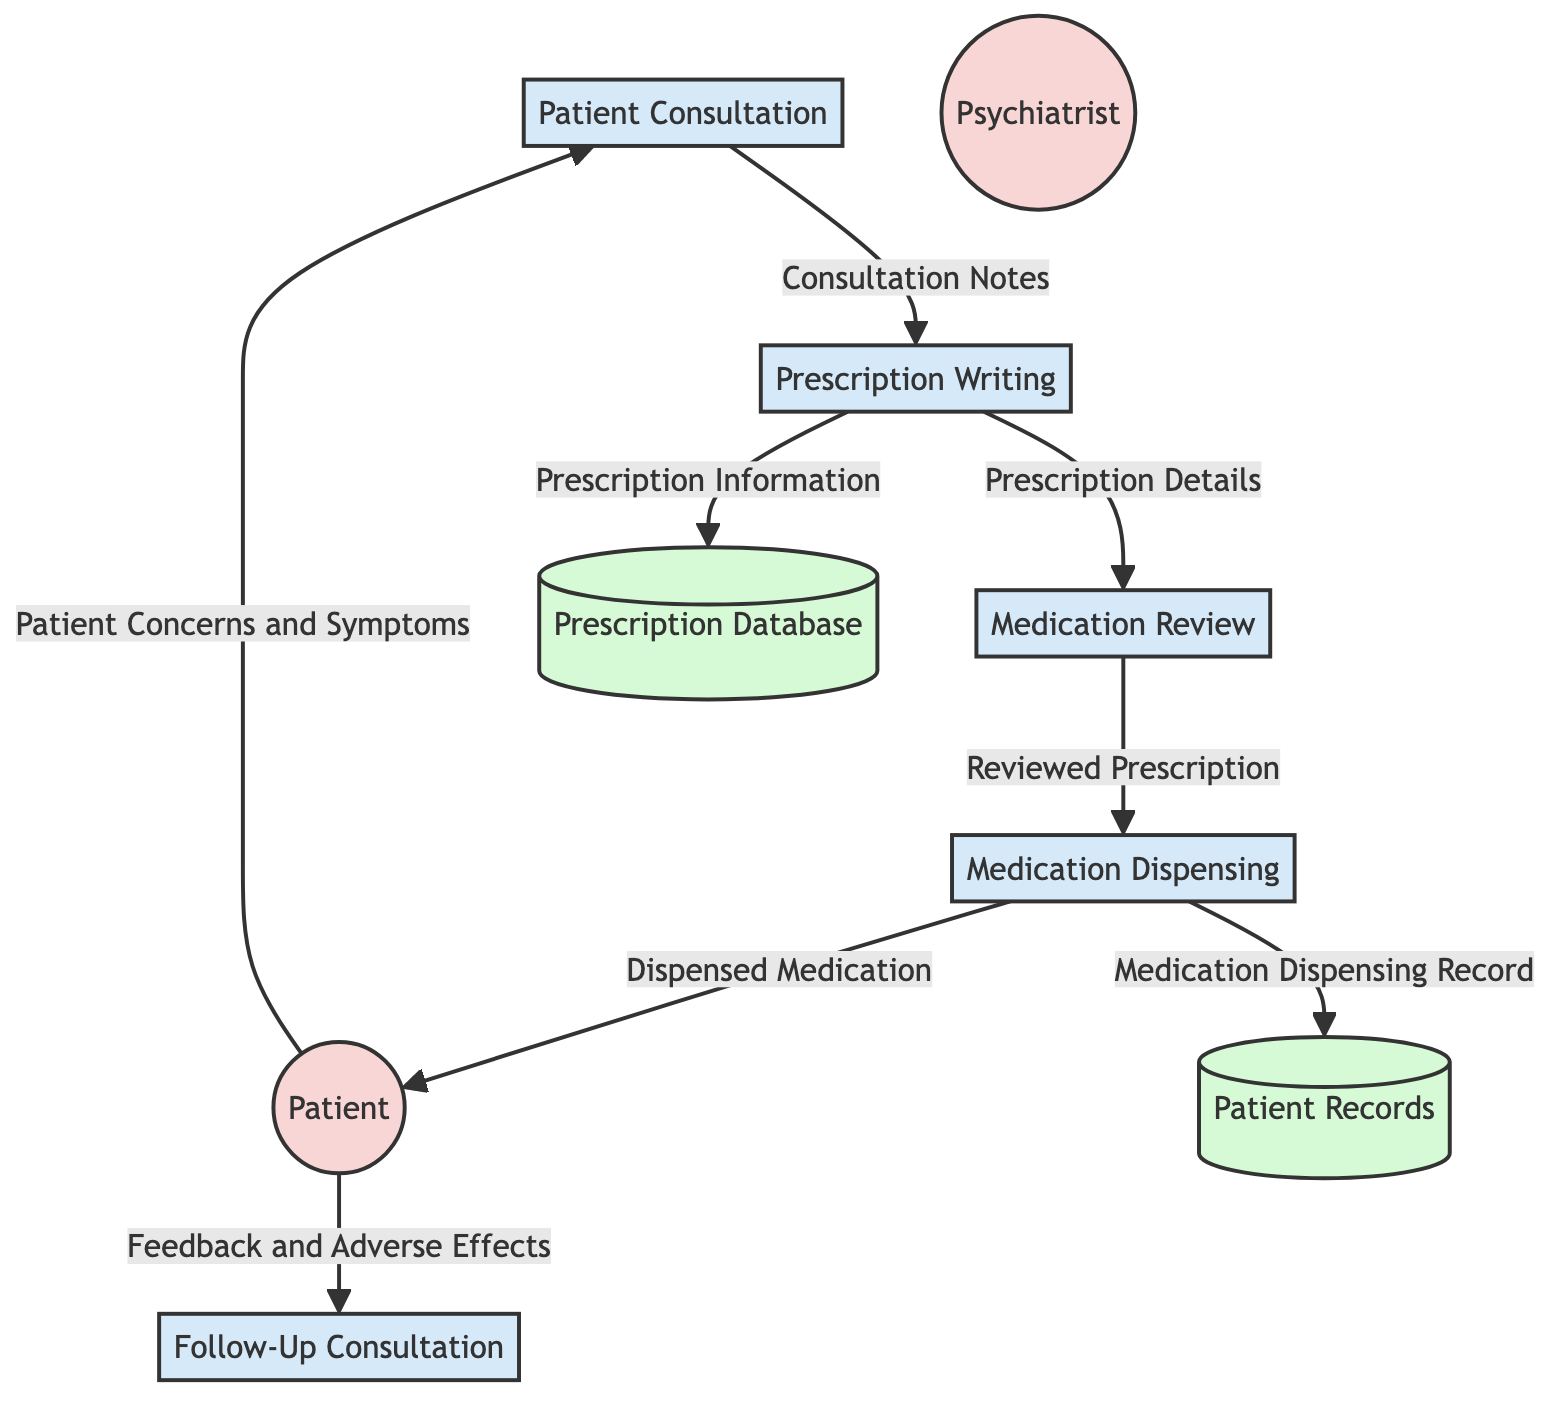What is the first process in the medication prescription process? The diagram shows that "Patient Consultation" is labeled as the first process, indicating it's the initial step in the flow of medication management for psychiatric patients.
Answer: Patient Consultation How many external entities are present in the diagram? By counting the external entities listed, we can see there are two: "Patient" and "Psychiatrist". This confirms a total count of two external entities.
Answer: 2 What data flows from the Psychiatrist to the Medication Review? The diagram indicates that "Prescription Details" flow from the "Prescription Writing" process to the "Medication Review". As the Psychiatrist is the one writing the prescription, the connection shows that the details are crucial for review.
Answer: Prescription Details What action happens after the Medication Review process? The diagram shows an arrow leading from "Medication Review" to "Medication Dispensing", indicating that the action that follows reviewing the prescription is dispensing the medication.
Answer: Medication Dispensing Which data store contains the patient's medical history? According to the diagram, "Patient Records" is the data store designated for housing the patient's medical history and consultation notes.
Answer: Patient Records What type of feedback does the patient provide during the Follow-Up Consultation? The diagram specifies that the feedback provided during the "Follow-Up Consultation" consists of "Feedback and Adverse Effects", which refers to the patient's experiences with the medication.
Answer: Feedback and Adverse Effects What process involves writing a prescription based on consultation? The "Prescription Writing" process is specifically designed to capture the act of writing a prescription to be given to the pharmacist after a consultation with the patient.
Answer: Prescription Writing Which process directly outputs the "Dispensed Medication"? The "Medication Dispensing" process is clearly indicated to result in "Dispensed Medication" being delivered to the patient following the review and approval of the prescription.
Answer: Medication Dispensing What is the primary input to the Patient Consultation process? The initial input to the "Patient Consultation" process is "Patient Concerns and Symptoms" provided by the patient, serving as the starting point for the consultation.
Answer: Patient Concerns and Symptoms 